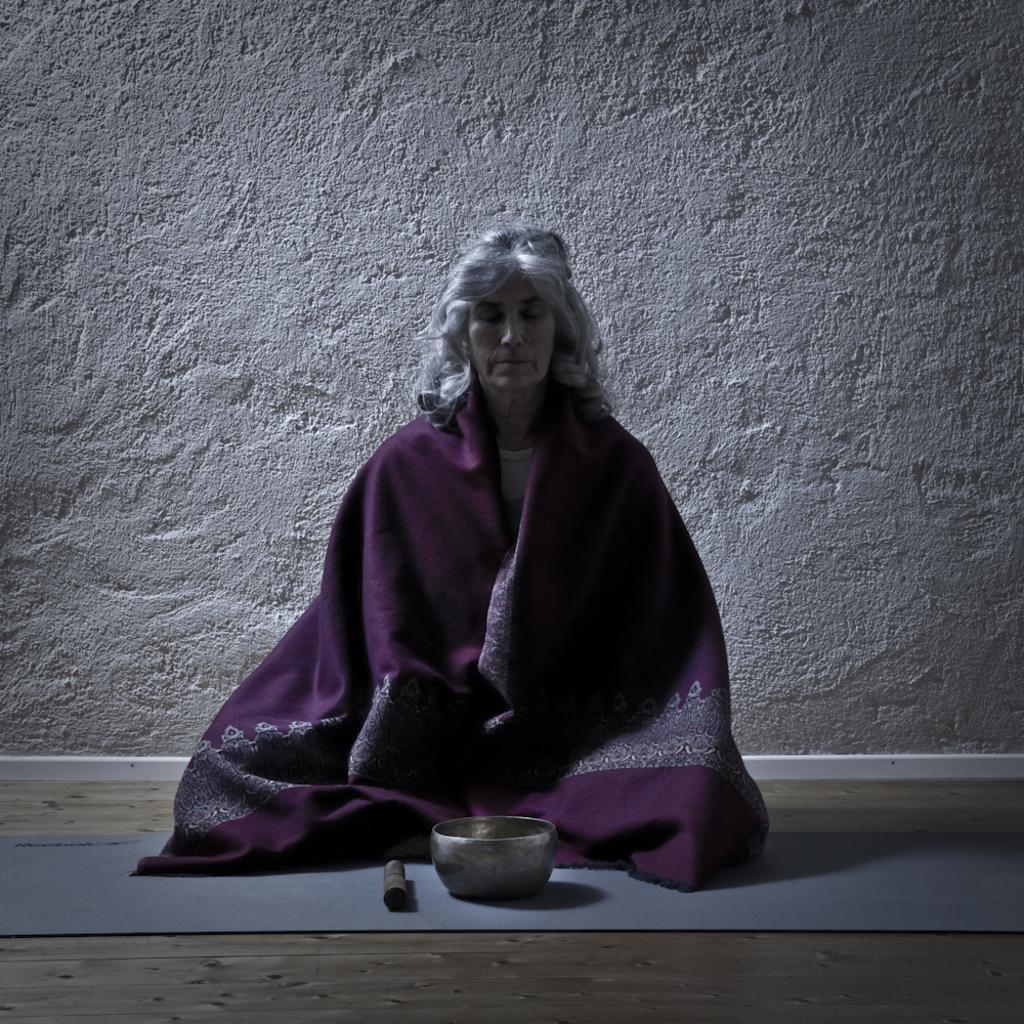Can you describe this image briefly? In this image, we can see a person sitting and we can see a bowl on the ground. We can see the wall. 